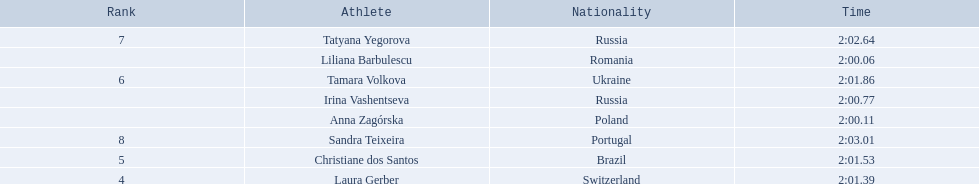What were all the finishing times? 2:00.06, 2:00.11, 2:00.77, 2:01.39, 2:01.53, 2:01.86, 2:02.64, 2:03.01. Which of these is anna zagorska's? 2:00.11. 